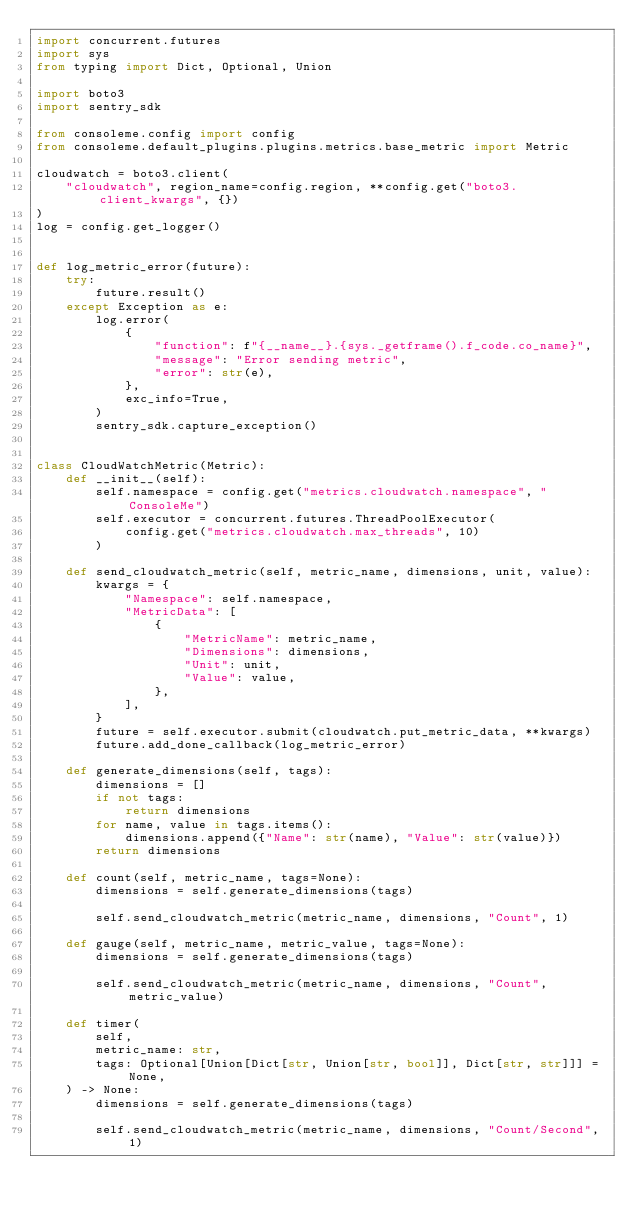<code> <loc_0><loc_0><loc_500><loc_500><_Python_>import concurrent.futures
import sys
from typing import Dict, Optional, Union

import boto3
import sentry_sdk

from consoleme.config import config
from consoleme.default_plugins.plugins.metrics.base_metric import Metric

cloudwatch = boto3.client(
    "cloudwatch", region_name=config.region, **config.get("boto3.client_kwargs", {})
)
log = config.get_logger()


def log_metric_error(future):
    try:
        future.result()
    except Exception as e:
        log.error(
            {
                "function": f"{__name__}.{sys._getframe().f_code.co_name}",
                "message": "Error sending metric",
                "error": str(e),
            },
            exc_info=True,
        )
        sentry_sdk.capture_exception()


class CloudWatchMetric(Metric):
    def __init__(self):
        self.namespace = config.get("metrics.cloudwatch.namespace", "ConsoleMe")
        self.executor = concurrent.futures.ThreadPoolExecutor(
            config.get("metrics.cloudwatch.max_threads", 10)
        )

    def send_cloudwatch_metric(self, metric_name, dimensions, unit, value):
        kwargs = {
            "Namespace": self.namespace,
            "MetricData": [
                {
                    "MetricName": metric_name,
                    "Dimensions": dimensions,
                    "Unit": unit,
                    "Value": value,
                },
            ],
        }
        future = self.executor.submit(cloudwatch.put_metric_data, **kwargs)
        future.add_done_callback(log_metric_error)

    def generate_dimensions(self, tags):
        dimensions = []
        if not tags:
            return dimensions
        for name, value in tags.items():
            dimensions.append({"Name": str(name), "Value": str(value)})
        return dimensions

    def count(self, metric_name, tags=None):
        dimensions = self.generate_dimensions(tags)

        self.send_cloudwatch_metric(metric_name, dimensions, "Count", 1)

    def gauge(self, metric_name, metric_value, tags=None):
        dimensions = self.generate_dimensions(tags)

        self.send_cloudwatch_metric(metric_name, dimensions, "Count", metric_value)

    def timer(
        self,
        metric_name: str,
        tags: Optional[Union[Dict[str, Union[str, bool]], Dict[str, str]]] = None,
    ) -> None:
        dimensions = self.generate_dimensions(tags)

        self.send_cloudwatch_metric(metric_name, dimensions, "Count/Second", 1)
</code> 